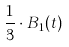<formula> <loc_0><loc_0><loc_500><loc_500>\frac { 1 } { 3 } \cdot B _ { 1 } ( t )</formula> 